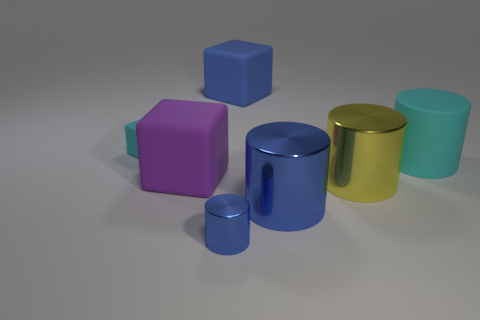Subtract all large yellow metal cylinders. How many cylinders are left? 3 Subtract all yellow cylinders. How many cylinders are left? 3 Subtract all cylinders. How many objects are left? 3 Subtract all gray blocks. Subtract all brown spheres. How many blocks are left? 3 Subtract all red blocks. How many brown cylinders are left? 0 Subtract all large green metallic cubes. Subtract all metal objects. How many objects are left? 4 Add 7 small metallic objects. How many small metallic objects are left? 8 Add 7 big purple metallic cubes. How many big purple metallic cubes exist? 7 Add 3 small cubes. How many objects exist? 10 Subtract 0 gray spheres. How many objects are left? 7 